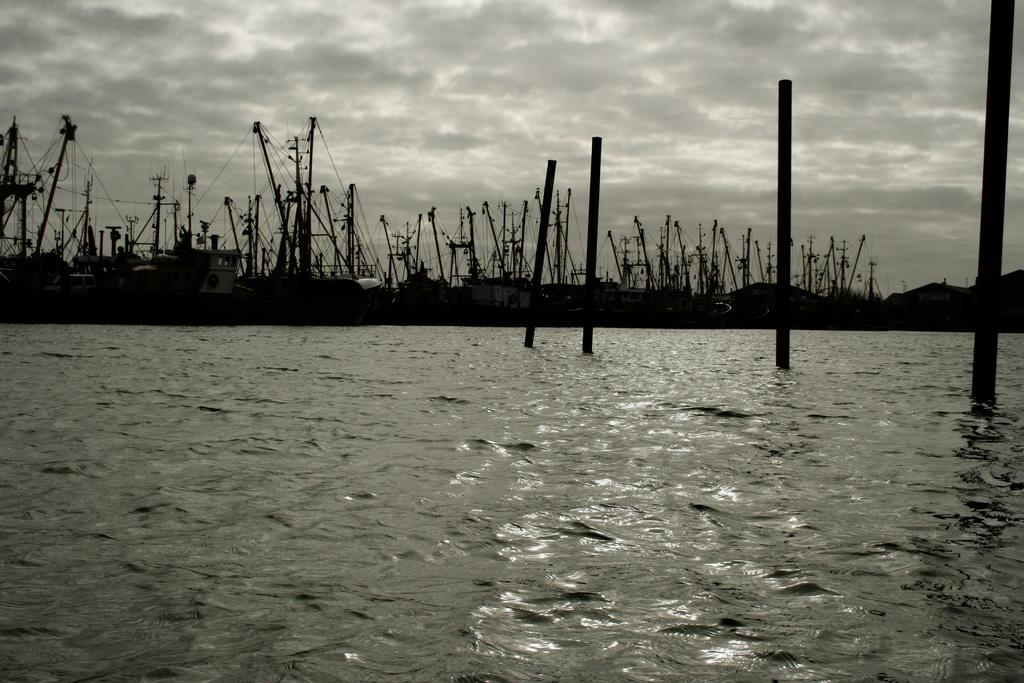What type of vehicles can be seen in the image? There are ships in the image. What structures are present in the image? There are poles in the image. Where are the ships and poles located? The ships and poles are on the water. What can be seen in the background of the image? There are clouds and the sky visible in the background of the image. What type of locket is hanging from the pole in the image? There is no locket present in the image; the poles are not adorned with any jewelry. 